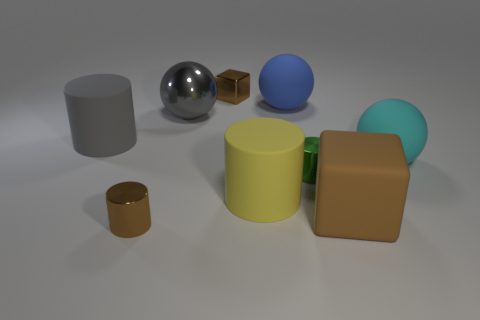Subtract all cubes. How many objects are left? 7 Subtract 0 blue blocks. How many objects are left? 9 Subtract all gray cylinders. Subtract all tiny metal cylinders. How many objects are left? 6 Add 8 green metallic cylinders. How many green metallic cylinders are left? 9 Add 9 big blue matte spheres. How many big blue matte spheres exist? 10 